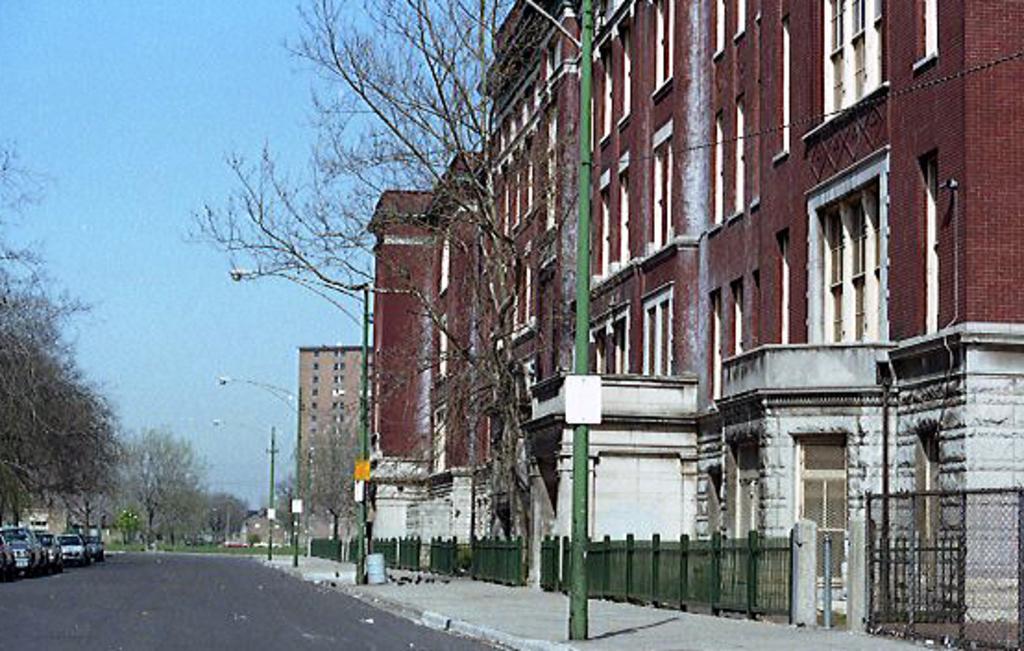Describe this image in one or two sentences. In the foreground of this image, there is a road, few vehicles, trees, poles, railing, fencing and buildings. At the top, there is the sky. 